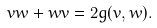<formula> <loc_0><loc_0><loc_500><loc_500>v w + w v = 2 g ( v , w ) .</formula> 